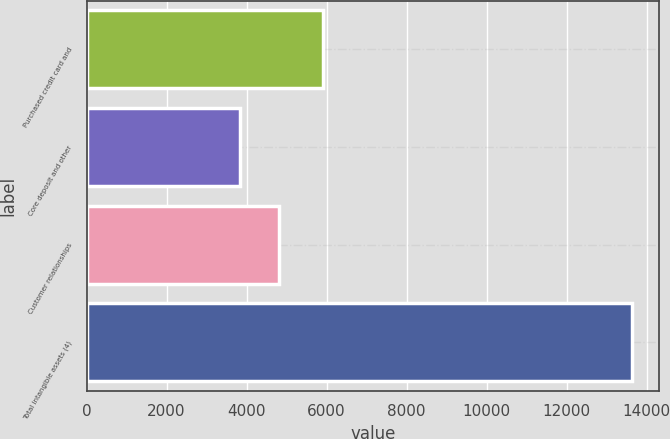Convert chart. <chart><loc_0><loc_0><loc_500><loc_500><bar_chart><fcel>Purchased credit card and<fcel>Core deposit and other<fcel>Customer relationships<fcel>Total intangible assets (4)<nl><fcel>5919<fcel>3835<fcel>4815.5<fcel>13640<nl></chart> 